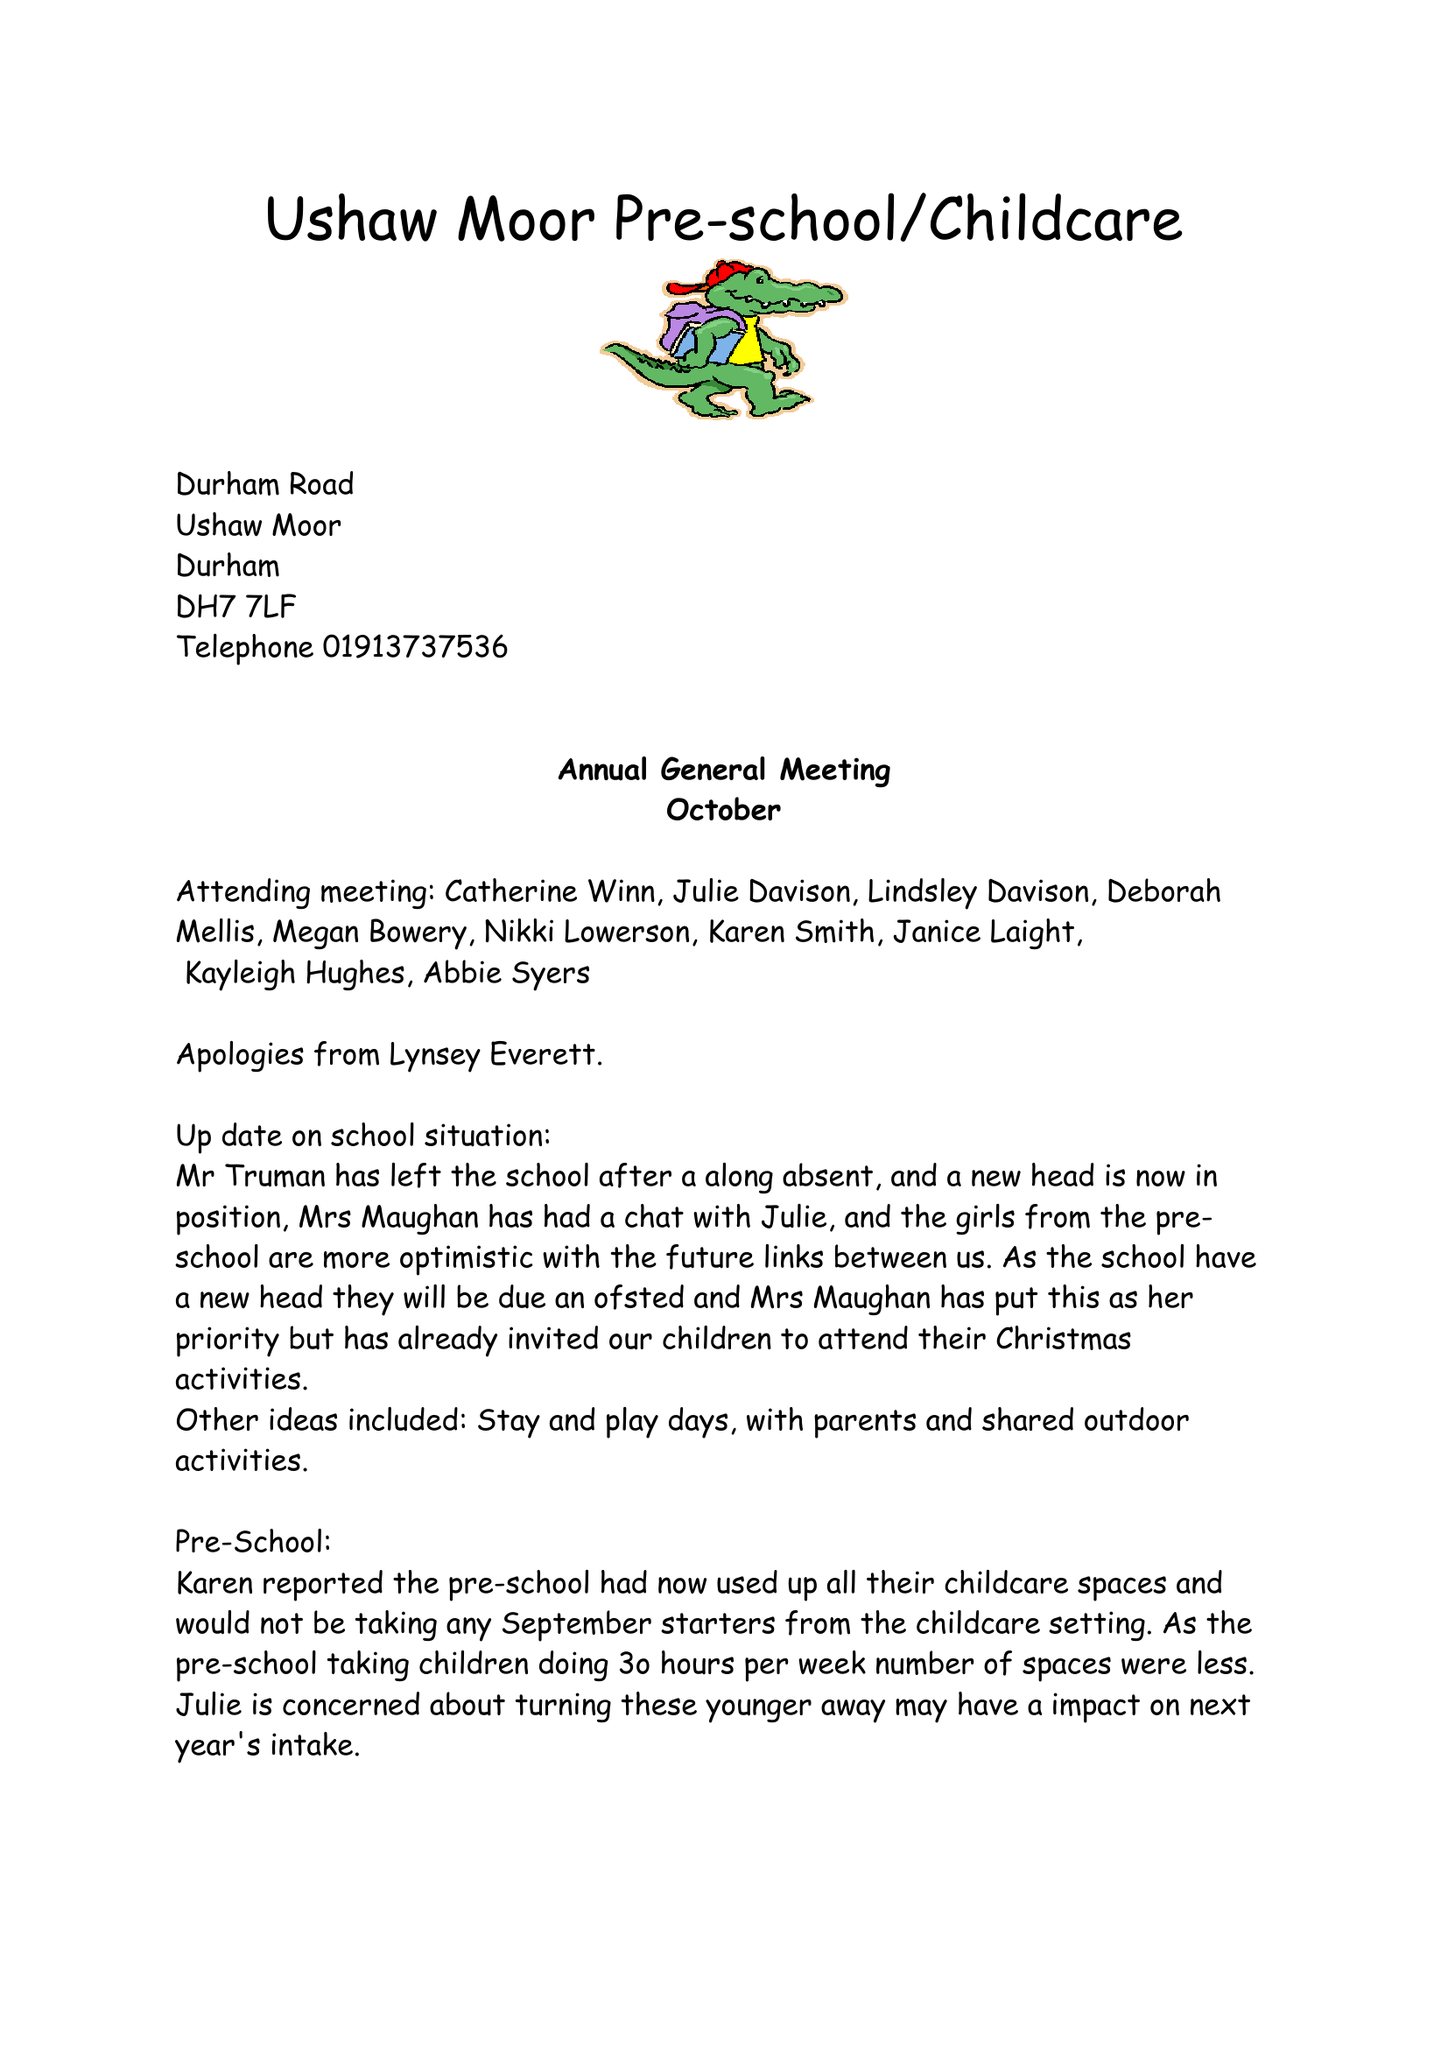What is the value for the address__street_line?
Answer the question using a single word or phrase. 9 ASH AVENUE 